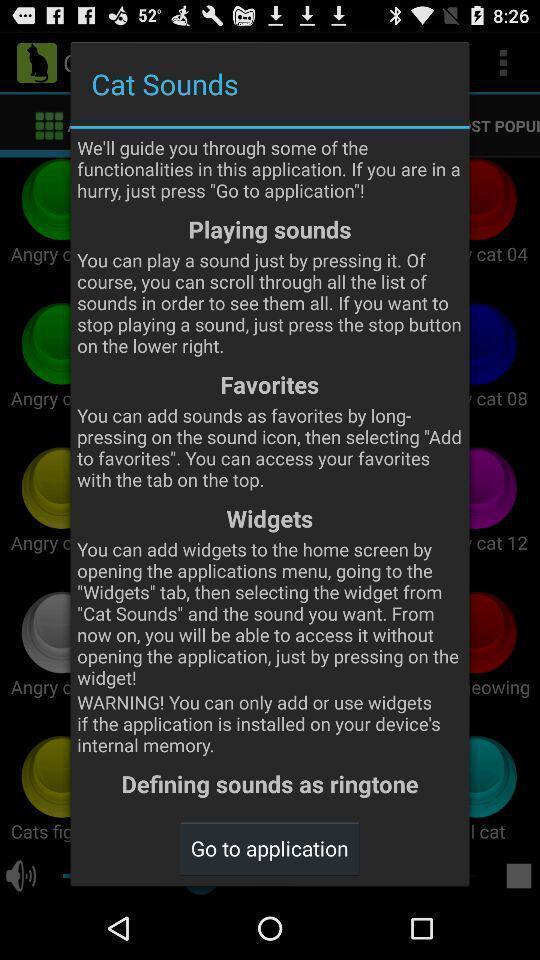Provide a description of this screenshot. Pop-up guiding functions of the ringtones app. 